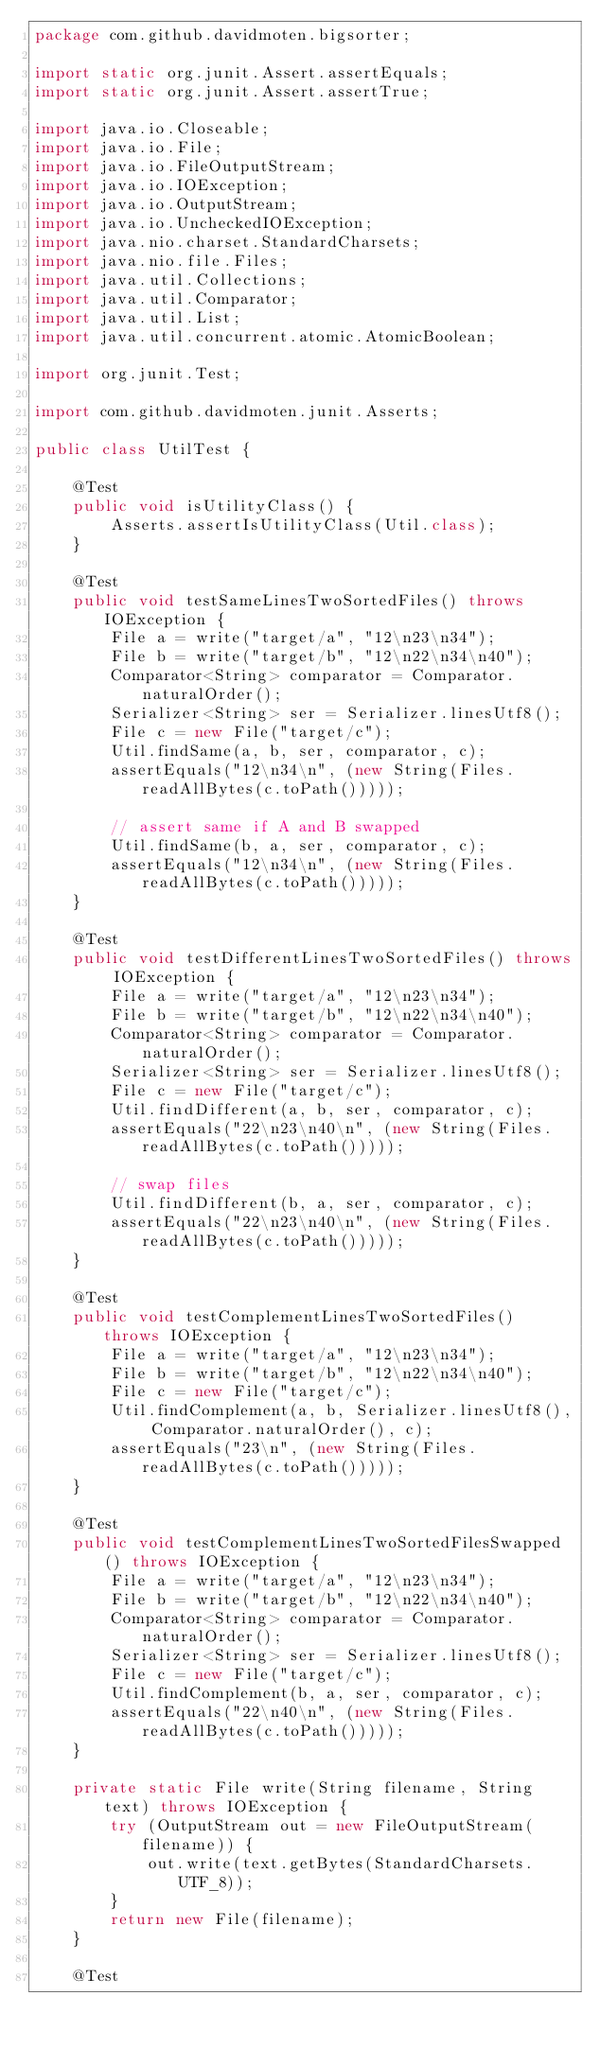<code> <loc_0><loc_0><loc_500><loc_500><_Java_>package com.github.davidmoten.bigsorter;

import static org.junit.Assert.assertEquals;
import static org.junit.Assert.assertTrue;

import java.io.Closeable;
import java.io.File;
import java.io.FileOutputStream;
import java.io.IOException;
import java.io.OutputStream;
import java.io.UncheckedIOException;
import java.nio.charset.StandardCharsets;
import java.nio.file.Files;
import java.util.Collections;
import java.util.Comparator;
import java.util.List;
import java.util.concurrent.atomic.AtomicBoolean;

import org.junit.Test;

import com.github.davidmoten.junit.Asserts;

public class UtilTest {

    @Test
    public void isUtilityClass() {
        Asserts.assertIsUtilityClass(Util.class);
    }

    @Test
    public void testSameLinesTwoSortedFiles() throws IOException {
        File a = write("target/a", "12\n23\n34");
        File b = write("target/b", "12\n22\n34\n40");
        Comparator<String> comparator = Comparator.naturalOrder();
        Serializer<String> ser = Serializer.linesUtf8();
        File c = new File("target/c");
        Util.findSame(a, b, ser, comparator, c);
        assertEquals("12\n34\n", (new String(Files.readAllBytes(c.toPath()))));

        // assert same if A and B swapped
        Util.findSame(b, a, ser, comparator, c);
        assertEquals("12\n34\n", (new String(Files.readAllBytes(c.toPath()))));
    }

    @Test
    public void testDifferentLinesTwoSortedFiles() throws IOException {
        File a = write("target/a", "12\n23\n34");
        File b = write("target/b", "12\n22\n34\n40");
        Comparator<String> comparator = Comparator.naturalOrder();
        Serializer<String> ser = Serializer.linesUtf8();
        File c = new File("target/c");
        Util.findDifferent(a, b, ser, comparator, c);
        assertEquals("22\n23\n40\n", (new String(Files.readAllBytes(c.toPath()))));

        // swap files
        Util.findDifferent(b, a, ser, comparator, c);
        assertEquals("22\n23\n40\n", (new String(Files.readAllBytes(c.toPath()))));
    }

    @Test
    public void testComplementLinesTwoSortedFiles() throws IOException {
        File a = write("target/a", "12\n23\n34");
        File b = write("target/b", "12\n22\n34\n40");
        File c = new File("target/c");
        Util.findComplement(a, b, Serializer.linesUtf8(), Comparator.naturalOrder(), c);
        assertEquals("23\n", (new String(Files.readAllBytes(c.toPath()))));
    }

    @Test
    public void testComplementLinesTwoSortedFilesSwapped() throws IOException {
        File a = write("target/a", "12\n23\n34");
        File b = write("target/b", "12\n22\n34\n40");
        Comparator<String> comparator = Comparator.naturalOrder();
        Serializer<String> ser = Serializer.linesUtf8();
        File c = new File("target/c");
        Util.findComplement(b, a, ser, comparator, c);
        assertEquals("22\n40\n", (new String(Files.readAllBytes(c.toPath()))));
    }

    private static File write(String filename, String text) throws IOException {
        try (OutputStream out = new FileOutputStream(filename)) {
            out.write(text.getBytes(StandardCharsets.UTF_8));
        }
        return new File(filename);
    }

    @Test</code> 